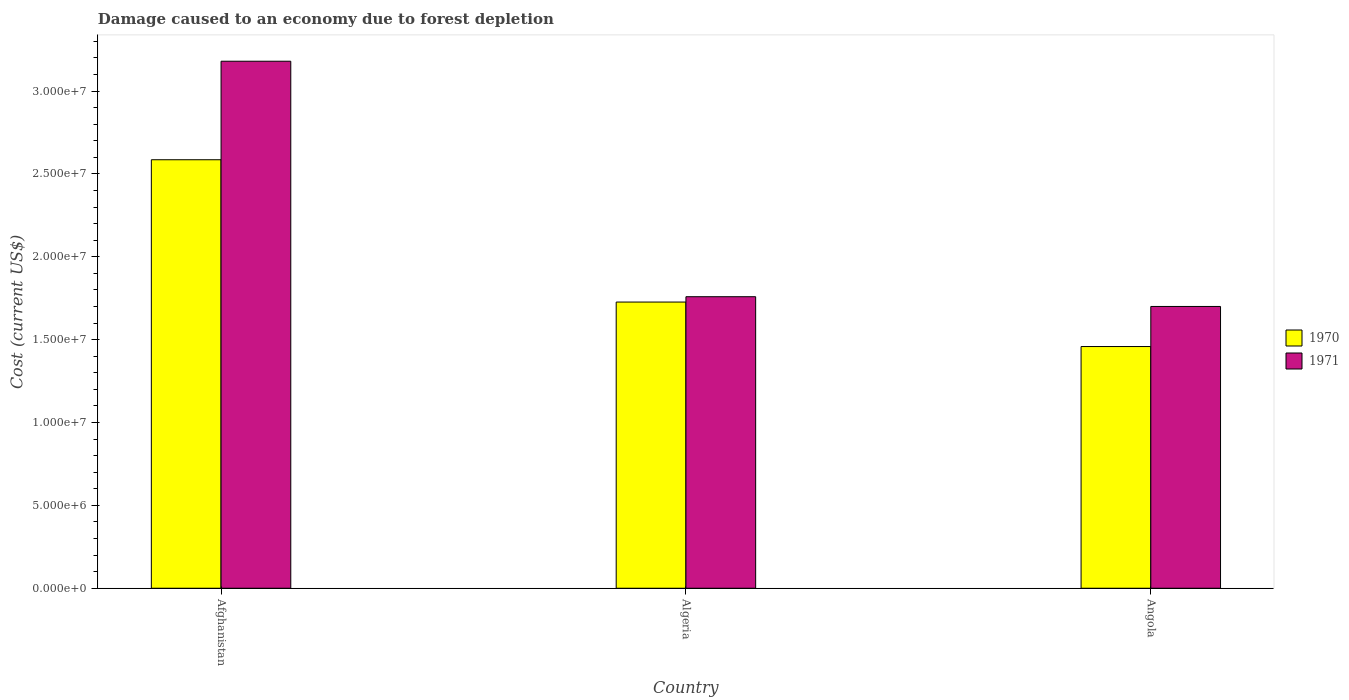How many different coloured bars are there?
Your answer should be compact. 2. How many bars are there on the 2nd tick from the left?
Give a very brief answer. 2. What is the label of the 3rd group of bars from the left?
Provide a short and direct response. Angola. In how many cases, is the number of bars for a given country not equal to the number of legend labels?
Offer a terse response. 0. What is the cost of damage caused due to forest depletion in 1971 in Algeria?
Make the answer very short. 1.76e+07. Across all countries, what is the maximum cost of damage caused due to forest depletion in 1970?
Give a very brief answer. 2.59e+07. Across all countries, what is the minimum cost of damage caused due to forest depletion in 1971?
Provide a succinct answer. 1.70e+07. In which country was the cost of damage caused due to forest depletion in 1970 maximum?
Provide a succinct answer. Afghanistan. In which country was the cost of damage caused due to forest depletion in 1971 minimum?
Keep it short and to the point. Angola. What is the total cost of damage caused due to forest depletion in 1970 in the graph?
Ensure brevity in your answer.  5.77e+07. What is the difference between the cost of damage caused due to forest depletion in 1970 in Afghanistan and that in Angola?
Make the answer very short. 1.13e+07. What is the difference between the cost of damage caused due to forest depletion in 1971 in Algeria and the cost of damage caused due to forest depletion in 1970 in Angola?
Ensure brevity in your answer.  3.01e+06. What is the average cost of damage caused due to forest depletion in 1970 per country?
Make the answer very short. 1.92e+07. What is the difference between the cost of damage caused due to forest depletion of/in 1971 and cost of damage caused due to forest depletion of/in 1970 in Angola?
Your answer should be compact. 2.42e+06. What is the ratio of the cost of damage caused due to forest depletion in 1970 in Afghanistan to that in Algeria?
Your answer should be compact. 1.5. Is the cost of damage caused due to forest depletion in 1971 in Afghanistan less than that in Algeria?
Your response must be concise. No. What is the difference between the highest and the second highest cost of damage caused due to forest depletion in 1970?
Provide a succinct answer. 8.59e+06. What is the difference between the highest and the lowest cost of damage caused due to forest depletion in 1970?
Offer a very short reply. 1.13e+07. In how many countries, is the cost of damage caused due to forest depletion in 1970 greater than the average cost of damage caused due to forest depletion in 1970 taken over all countries?
Your response must be concise. 1. Is the sum of the cost of damage caused due to forest depletion in 1970 in Afghanistan and Algeria greater than the maximum cost of damage caused due to forest depletion in 1971 across all countries?
Make the answer very short. Yes. What does the 1st bar from the left in Afghanistan represents?
Your answer should be very brief. 1970. What does the 2nd bar from the right in Afghanistan represents?
Provide a short and direct response. 1970. How many countries are there in the graph?
Your answer should be compact. 3. Are the values on the major ticks of Y-axis written in scientific E-notation?
Provide a short and direct response. Yes. Does the graph contain any zero values?
Give a very brief answer. No. Does the graph contain grids?
Make the answer very short. No. Where does the legend appear in the graph?
Your answer should be compact. Center right. What is the title of the graph?
Give a very brief answer. Damage caused to an economy due to forest depletion. What is the label or title of the Y-axis?
Offer a very short reply. Cost (current US$). What is the Cost (current US$) in 1970 in Afghanistan?
Ensure brevity in your answer.  2.59e+07. What is the Cost (current US$) in 1971 in Afghanistan?
Provide a short and direct response. 3.18e+07. What is the Cost (current US$) of 1970 in Algeria?
Your response must be concise. 1.73e+07. What is the Cost (current US$) in 1971 in Algeria?
Provide a succinct answer. 1.76e+07. What is the Cost (current US$) of 1970 in Angola?
Your answer should be very brief. 1.46e+07. What is the Cost (current US$) of 1971 in Angola?
Ensure brevity in your answer.  1.70e+07. Across all countries, what is the maximum Cost (current US$) in 1970?
Offer a very short reply. 2.59e+07. Across all countries, what is the maximum Cost (current US$) in 1971?
Offer a very short reply. 3.18e+07. Across all countries, what is the minimum Cost (current US$) in 1970?
Your answer should be very brief. 1.46e+07. Across all countries, what is the minimum Cost (current US$) of 1971?
Make the answer very short. 1.70e+07. What is the total Cost (current US$) of 1970 in the graph?
Make the answer very short. 5.77e+07. What is the total Cost (current US$) in 1971 in the graph?
Your answer should be very brief. 6.64e+07. What is the difference between the Cost (current US$) of 1970 in Afghanistan and that in Algeria?
Your response must be concise. 8.59e+06. What is the difference between the Cost (current US$) of 1971 in Afghanistan and that in Algeria?
Your answer should be very brief. 1.42e+07. What is the difference between the Cost (current US$) of 1970 in Afghanistan and that in Angola?
Provide a short and direct response. 1.13e+07. What is the difference between the Cost (current US$) of 1971 in Afghanistan and that in Angola?
Your answer should be very brief. 1.48e+07. What is the difference between the Cost (current US$) in 1970 in Algeria and that in Angola?
Make the answer very short. 2.69e+06. What is the difference between the Cost (current US$) of 1971 in Algeria and that in Angola?
Provide a short and direct response. 5.88e+05. What is the difference between the Cost (current US$) of 1970 in Afghanistan and the Cost (current US$) of 1971 in Algeria?
Keep it short and to the point. 8.27e+06. What is the difference between the Cost (current US$) of 1970 in Afghanistan and the Cost (current US$) of 1971 in Angola?
Your response must be concise. 8.85e+06. What is the difference between the Cost (current US$) in 1970 in Algeria and the Cost (current US$) in 1971 in Angola?
Your response must be concise. 2.66e+05. What is the average Cost (current US$) of 1970 per country?
Make the answer very short. 1.92e+07. What is the average Cost (current US$) in 1971 per country?
Ensure brevity in your answer.  2.21e+07. What is the difference between the Cost (current US$) of 1970 and Cost (current US$) of 1971 in Afghanistan?
Your response must be concise. -5.95e+06. What is the difference between the Cost (current US$) of 1970 and Cost (current US$) of 1971 in Algeria?
Your answer should be compact. -3.23e+05. What is the difference between the Cost (current US$) of 1970 and Cost (current US$) of 1971 in Angola?
Offer a terse response. -2.42e+06. What is the ratio of the Cost (current US$) in 1970 in Afghanistan to that in Algeria?
Offer a very short reply. 1.5. What is the ratio of the Cost (current US$) of 1971 in Afghanistan to that in Algeria?
Provide a succinct answer. 1.81. What is the ratio of the Cost (current US$) of 1970 in Afghanistan to that in Angola?
Ensure brevity in your answer.  1.77. What is the ratio of the Cost (current US$) of 1971 in Afghanistan to that in Angola?
Ensure brevity in your answer.  1.87. What is the ratio of the Cost (current US$) of 1970 in Algeria to that in Angola?
Ensure brevity in your answer.  1.18. What is the ratio of the Cost (current US$) in 1971 in Algeria to that in Angola?
Your answer should be very brief. 1.03. What is the difference between the highest and the second highest Cost (current US$) in 1970?
Your response must be concise. 8.59e+06. What is the difference between the highest and the second highest Cost (current US$) in 1971?
Make the answer very short. 1.42e+07. What is the difference between the highest and the lowest Cost (current US$) of 1970?
Offer a terse response. 1.13e+07. What is the difference between the highest and the lowest Cost (current US$) of 1971?
Ensure brevity in your answer.  1.48e+07. 